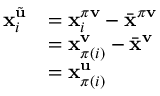<formula> <loc_0><loc_0><loc_500><loc_500>\begin{array} { r l } { x _ { i } ^ { \tilde { u } } } & { = x _ { i } ^ { \pi v } - \bar { x } ^ { \pi v } } \\ & { = x _ { \pi ( i ) } ^ { v } - \bar { x } ^ { v } } \\ & { = x _ { \pi ( i ) } ^ { u } } \end{array}</formula> 